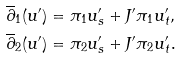<formula> <loc_0><loc_0><loc_500><loc_500>\overline { \partial } _ { 1 } ( u ^ { \prime } ) & = \pi _ { 1 } u ^ { \prime } _ { s } + J ^ { \prime } \pi _ { 1 } u ^ { \prime } _ { t } , \\ \overline { \partial } _ { 2 } ( u ^ { \prime } ) & = \pi _ { 2 } u ^ { \prime } _ { s } + J ^ { \prime } \pi _ { 2 } u ^ { \prime } _ { t } .</formula> 